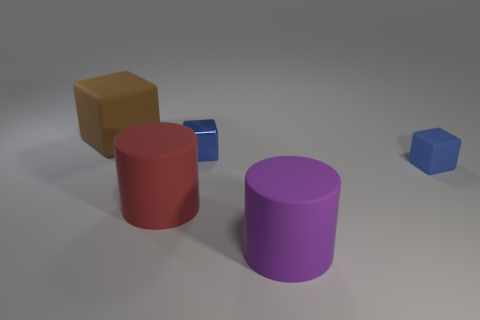Is there a shiny cube that has the same color as the tiny rubber object?
Keep it short and to the point. Yes. The brown object that is the same size as the purple thing is what shape?
Your response must be concise. Cube. There is a large brown block; are there any big red cylinders behind it?
Your response must be concise. No. Are the tiny thing to the left of the large purple matte object and the tiny blue block that is to the right of the blue shiny object made of the same material?
Keep it short and to the point. No. What number of purple things are the same size as the red thing?
Provide a succinct answer. 1. The tiny shiny object that is the same color as the tiny rubber thing is what shape?
Your answer should be very brief. Cube. There is a blue block that is to the right of the small blue shiny cube; what material is it?
Make the answer very short. Rubber. How many purple matte objects have the same shape as the brown thing?
Offer a very short reply. 0. The brown object that is the same material as the big red cylinder is what shape?
Make the answer very short. Cube. What shape is the large object that is on the right side of the rubber cylinder that is to the left of the blue block that is left of the tiny matte object?
Offer a very short reply. Cylinder. 